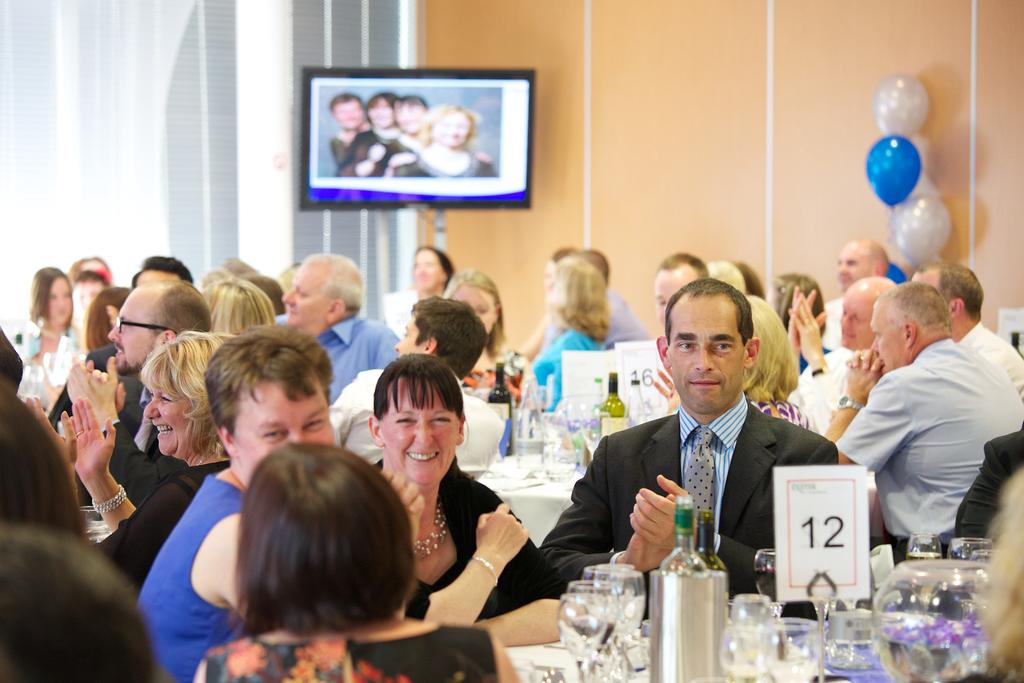How are the people arranged in the image? People are sitting in groups in the image. Where are the people sitting? The people are sitting at tables. What type of event is taking place in the image? The setting is a party. What type of bee can be seen buzzing around the party in the image? There is no bee present in the image; it is focused on the people sitting at tables. What songs are being played at the party in the image? The image does not provide any information about the music being played at the party. 